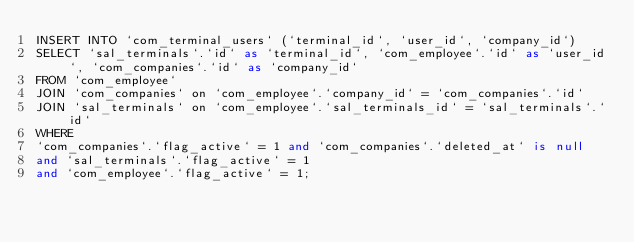Convert code to text. <code><loc_0><loc_0><loc_500><loc_500><_SQL_>INSERT INTO `com_terminal_users` (`terminal_id`, `user_id`, `company_id`) 
SELECT `sal_terminals`.`id` as `terminal_id`, `com_employee`.`id` as `user_id`, `com_companies`.`id` as `company_id`
FROM `com_employee` 
JOIN `com_companies` on `com_employee`.`company_id` = `com_companies`.`id` 
JOIN `sal_terminals` on `com_employee`.`sal_terminals_id` = `sal_terminals`.`id`
WHERE
`com_companies`.`flag_active` = 1 and `com_companies`.`deleted_at` is null
and `sal_terminals`.`flag_active` = 1
and `com_employee`.`flag_active` = 1;</code> 